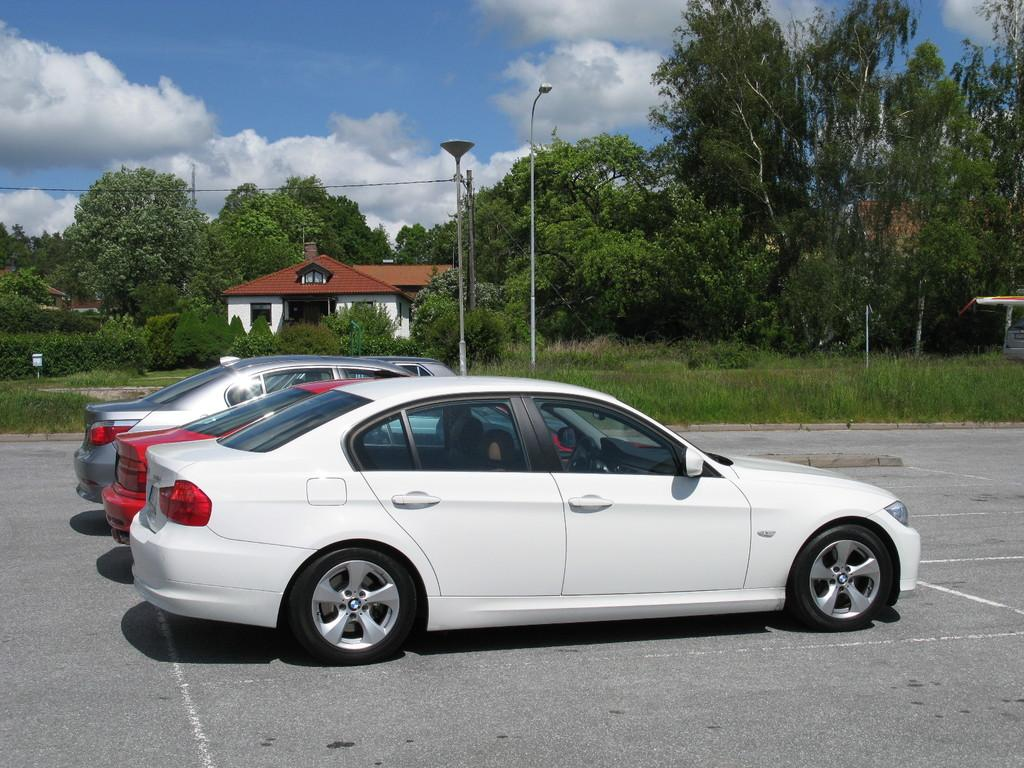What type of vehicles can be seen on the road in the image? There are cars on the road in the image. What can be seen in the background of the image? There are poles, trees, and a house in the background of the image. Where is the shop located in the image? There is no shop present in the image. What type of hole can be seen in the image? There is no hole present in the image. 